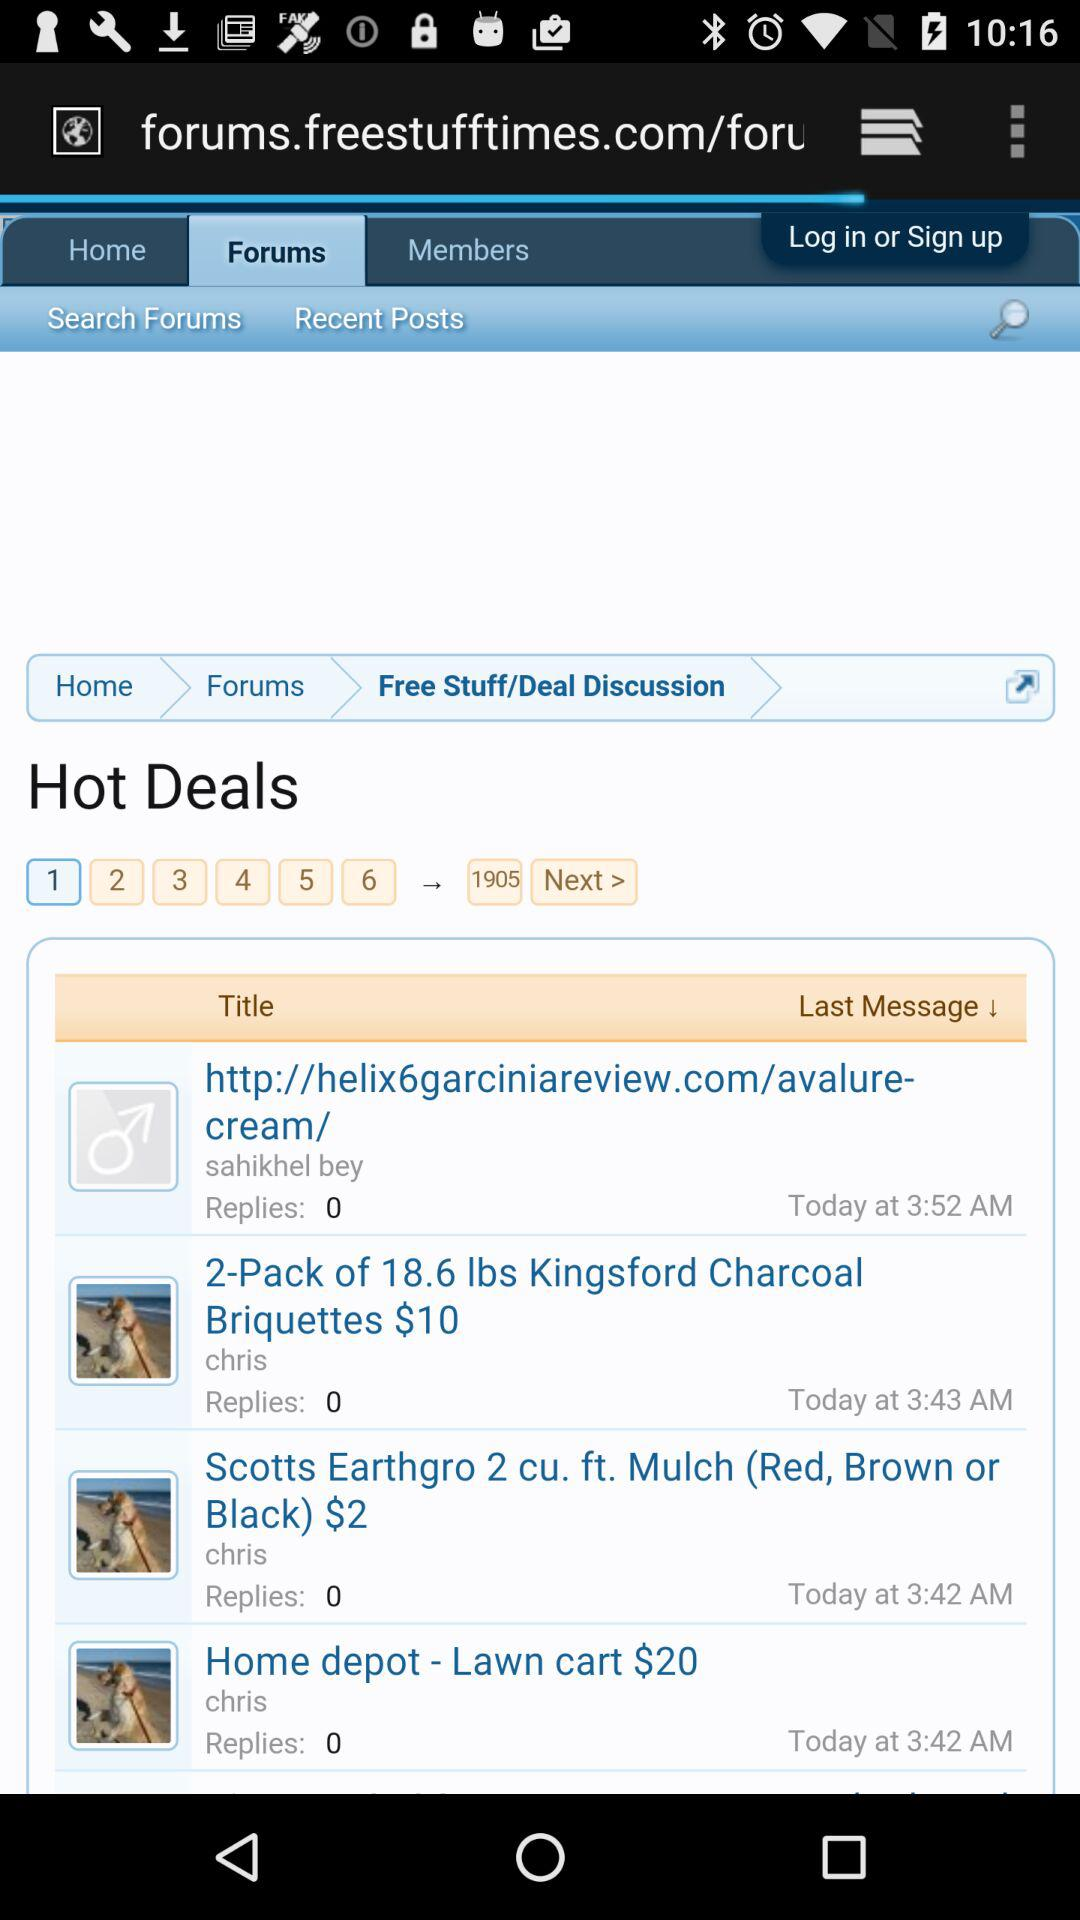Which page of hot deals am I on? You are on the first page of hot deals. 